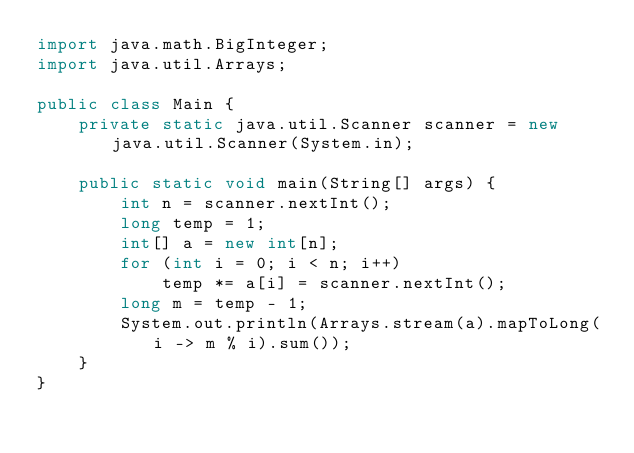<code> <loc_0><loc_0><loc_500><loc_500><_Java_>import java.math.BigInteger;
import java.util.Arrays;

public class Main {
    private static java.util.Scanner scanner = new java.util.Scanner(System.in);

    public static void main(String[] args) {
        int n = scanner.nextInt();
        long temp = 1;
        int[] a = new int[n];
        for (int i = 0; i < n; i++)
            temp *= a[i] = scanner.nextInt();
        long m = temp - 1;
        System.out.println(Arrays.stream(a).mapToLong(i -> m % i).sum());
    }
}</code> 